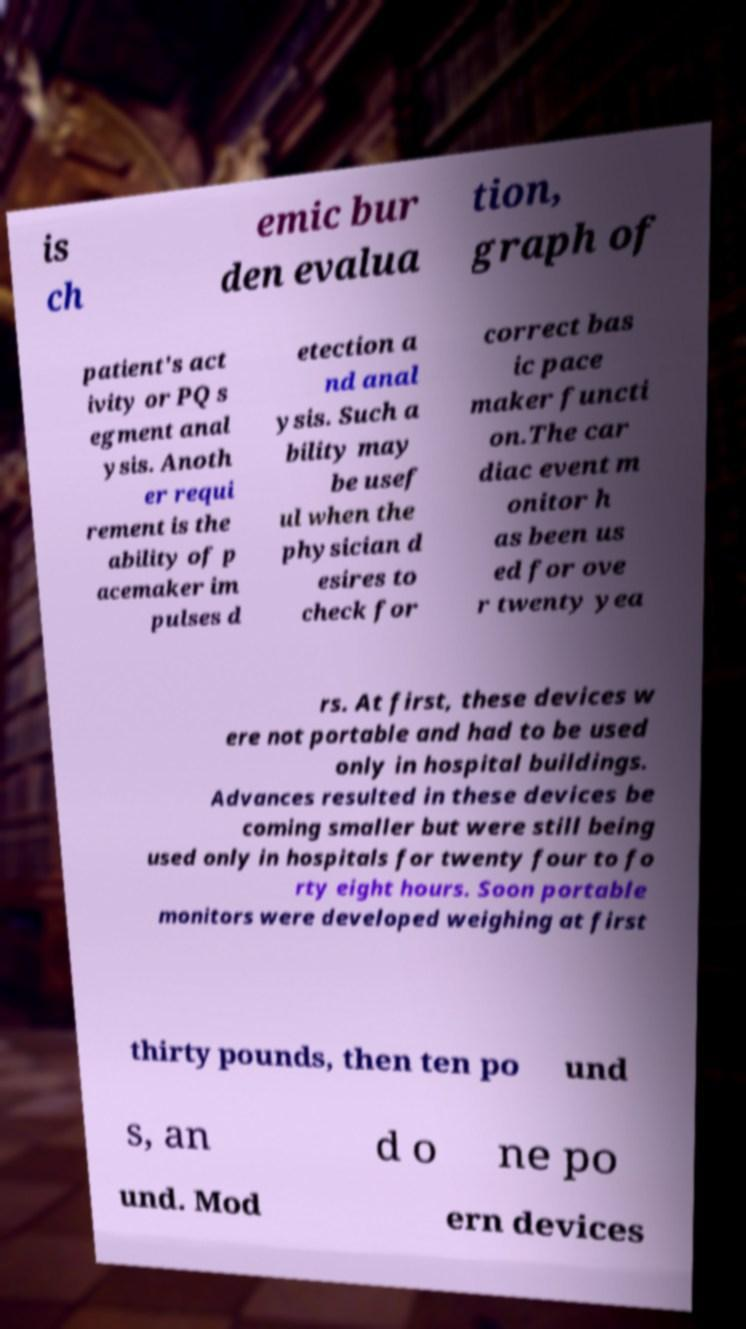Please identify and transcribe the text found in this image. is ch emic bur den evalua tion, graph of patient's act ivity or PQ s egment anal ysis. Anoth er requi rement is the ability of p acemaker im pulses d etection a nd anal ysis. Such a bility may be usef ul when the physician d esires to check for correct bas ic pace maker functi on.The car diac event m onitor h as been us ed for ove r twenty yea rs. At first, these devices w ere not portable and had to be used only in hospital buildings. Advances resulted in these devices be coming smaller but were still being used only in hospitals for twenty four to fo rty eight hours. Soon portable monitors were developed weighing at first thirty pounds, then ten po und s, an d o ne po und. Mod ern devices 